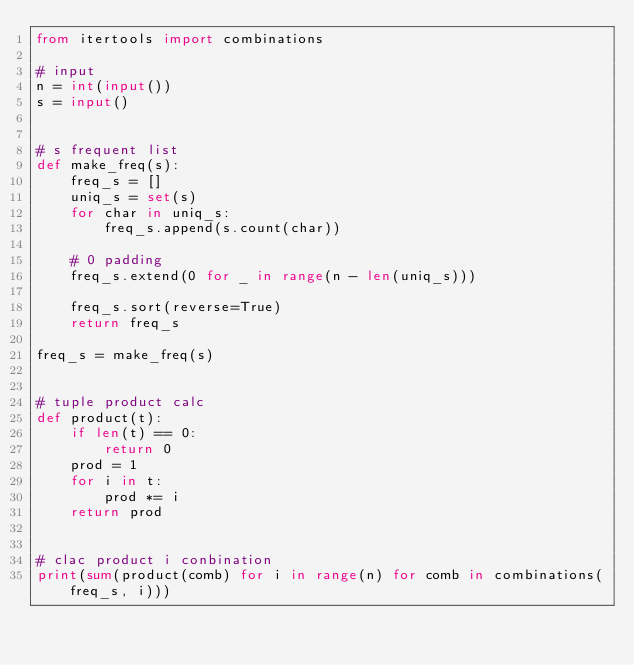Convert code to text. <code><loc_0><loc_0><loc_500><loc_500><_Python_>from itertools import combinations

# input
n = int(input())
s = input()


# s frequent list
def make_freq(s):
    freq_s = []
    uniq_s = set(s)
    for char in uniq_s:
        freq_s.append(s.count(char))

    # 0 padding
    freq_s.extend(0 for _ in range(n - len(uniq_s)))

    freq_s.sort(reverse=True)
    return freq_s

freq_s = make_freq(s)


# tuple product calc
def product(t):
    if len(t) == 0:
        return 0
    prod = 1
    for i in t:
        prod *= i
    return prod


# clac product i conbination
print(sum(product(comb) for i in range(n) for comb in combinations(freq_s, i)))
</code> 